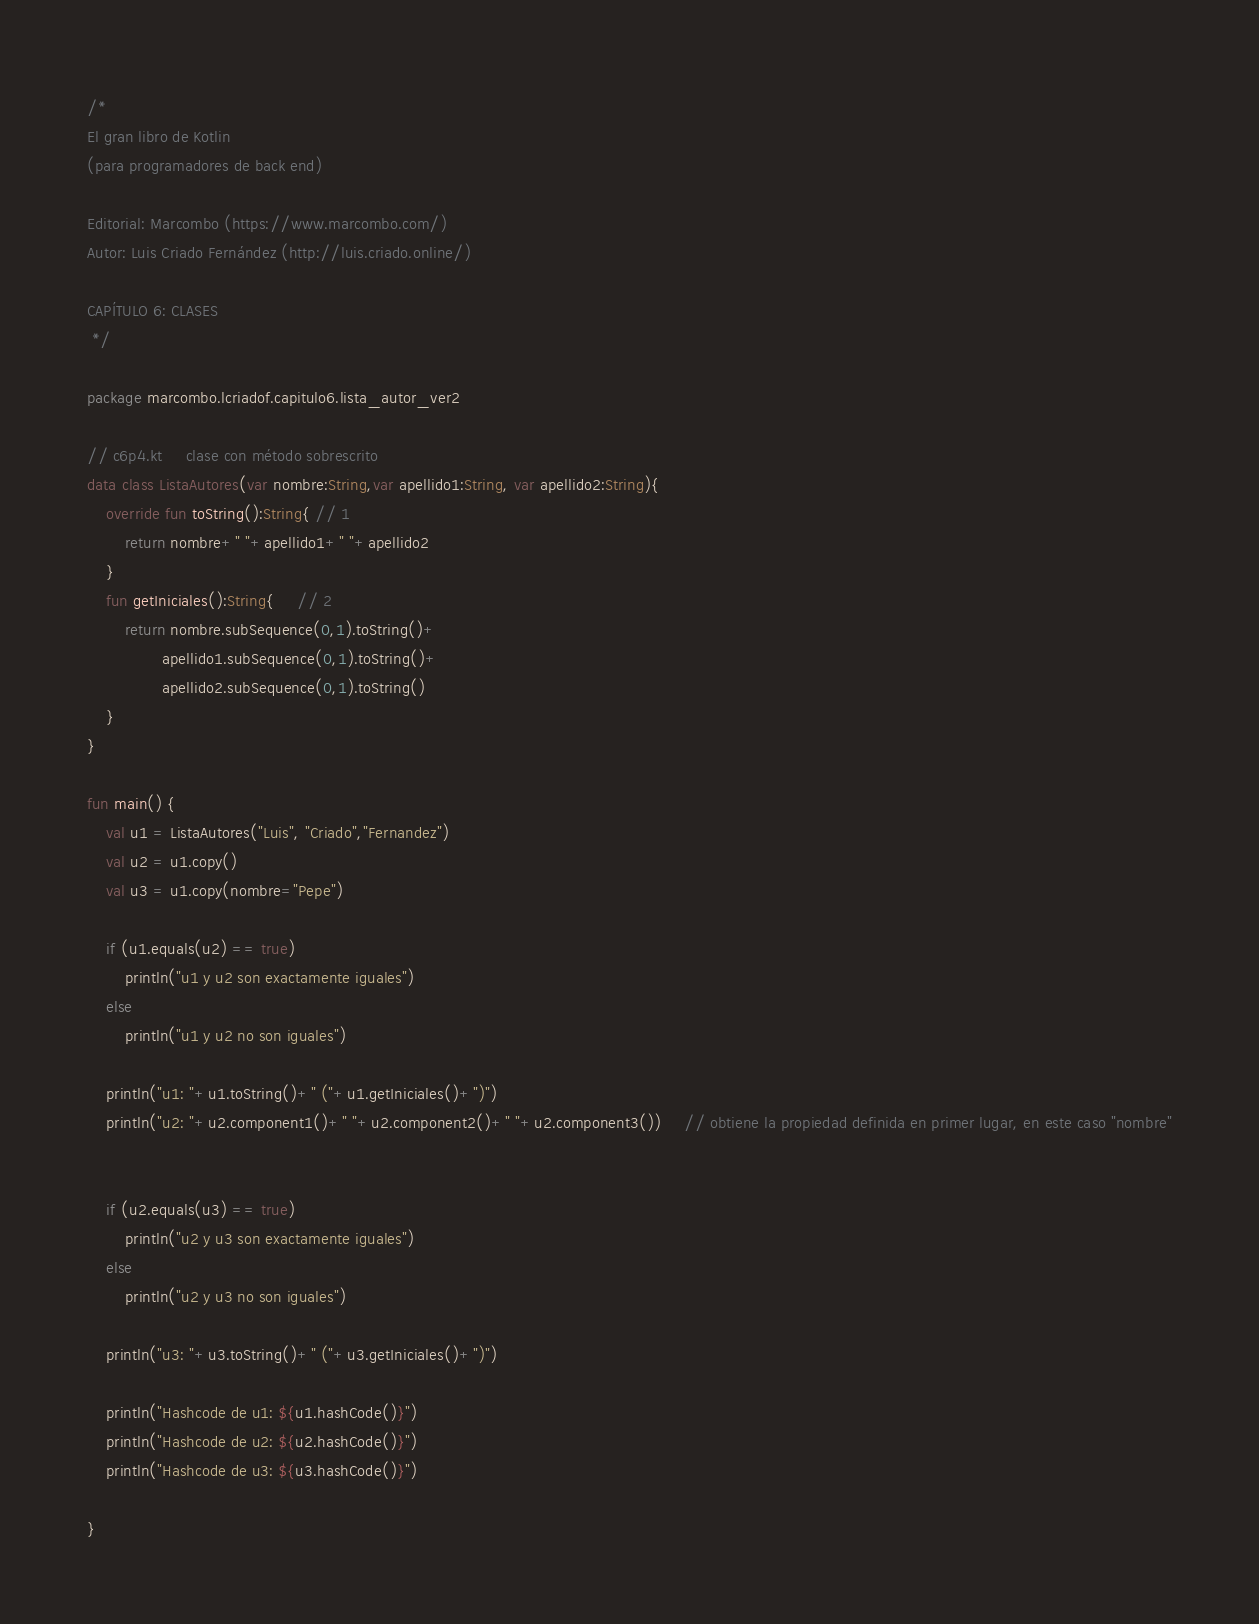Convert code to text. <code><loc_0><loc_0><loc_500><loc_500><_Kotlin_>/*
El gran libro de Kotlin
(para programadores de back end)

Editorial: Marcombo (https://www.marcombo.com/)
Autor: Luis Criado Fernández (http://luis.criado.online/)

CAPÍTULO 6: CLASES
 */

package marcombo.lcriadof.capitulo6.lista_autor_ver2

// c6p4.kt     clase con método sobrescrito
data class ListaAutores(var nombre:String,var apellido1:String, var apellido2:String){
    override fun toString():String{ // 1
        return nombre+" "+apellido1+" "+apellido2
    }
    fun getIniciales():String{     // 2
        return nombre.subSequence(0,1).toString()+
                apellido1.subSequence(0,1).toString()+
                apellido2.subSequence(0,1).toString()
    }
}

fun main() {
    val u1 = ListaAutores("Luis", "Criado","Fernandez")
    val u2 = u1.copy()
    val u3 = u1.copy(nombre="Pepe")

    if (u1.equals(u2) == true)
        println("u1 y u2 son exactamente iguales")
    else
        println("u1 y u2 no son iguales")

    println("u1: "+u1.toString()+" ("+u1.getIniciales()+")")
    println("u2: "+u2.component1()+" "+u2.component2()+" "+u2.component3())     // obtiene la propiedad definida en primer lugar, en este caso "nombre"


    if (u2.equals(u3) == true)
        println("u2 y u3 son exactamente iguales")
    else
        println("u2 y u3 no son iguales")

    println("u3: "+u3.toString()+" ("+u3.getIniciales()+")")

    println("Hashcode de u1: ${u1.hashCode()}")
    println("Hashcode de u2: ${u2.hashCode()}")
    println("Hashcode de u3: ${u3.hashCode()}")

}

</code> 